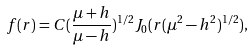<formula> <loc_0><loc_0><loc_500><loc_500>f ( r ) = C ( \frac { \mu + h } { \mu - h } ) ^ { 1 / 2 } J _ { 0 } ( r ( \mu ^ { 2 } - h ^ { 2 } ) ^ { 1 / 2 } ) ,</formula> 